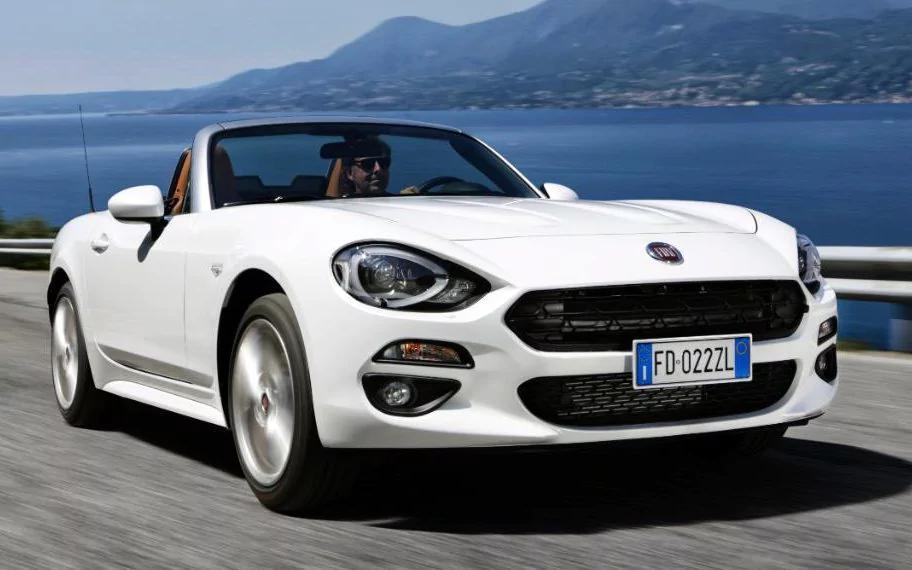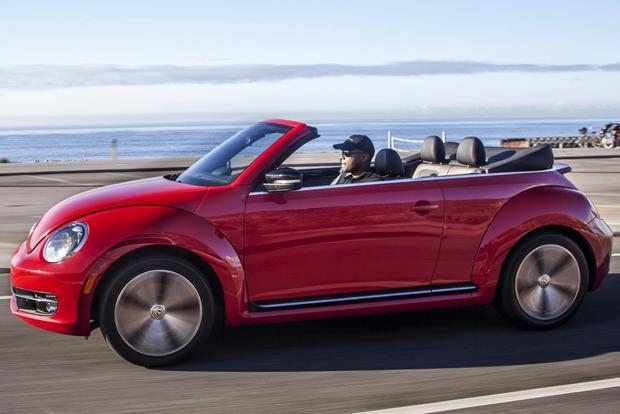The first image is the image on the left, the second image is the image on the right. Analyze the images presented: Is the assertion "There is a red convertible car in one image" valid? Answer yes or no. Yes. The first image is the image on the left, the second image is the image on the right. For the images shown, is this caption "There is a red convertible in one image." true? Answer yes or no. Yes. 